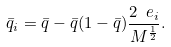Convert formula to latex. <formula><loc_0><loc_0><loc_500><loc_500>\bar { q } _ { i } = \bar { q } - \bar { q } ( 1 - \bar { q } ) \frac { 2 \ e _ { i } } { M ^ { \frac { 1 } { 2 } } } .</formula> 